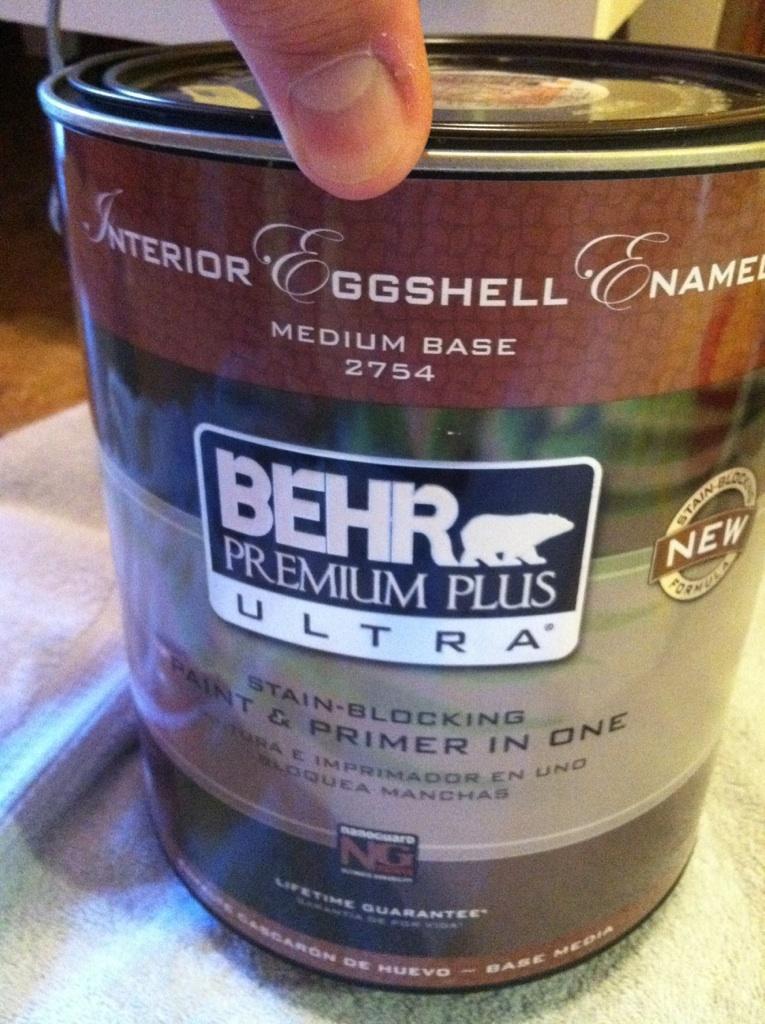In one or two sentences, can you explain what this image depicts? In this picture we can see a tin on the platform, where we can see a person's finger. 